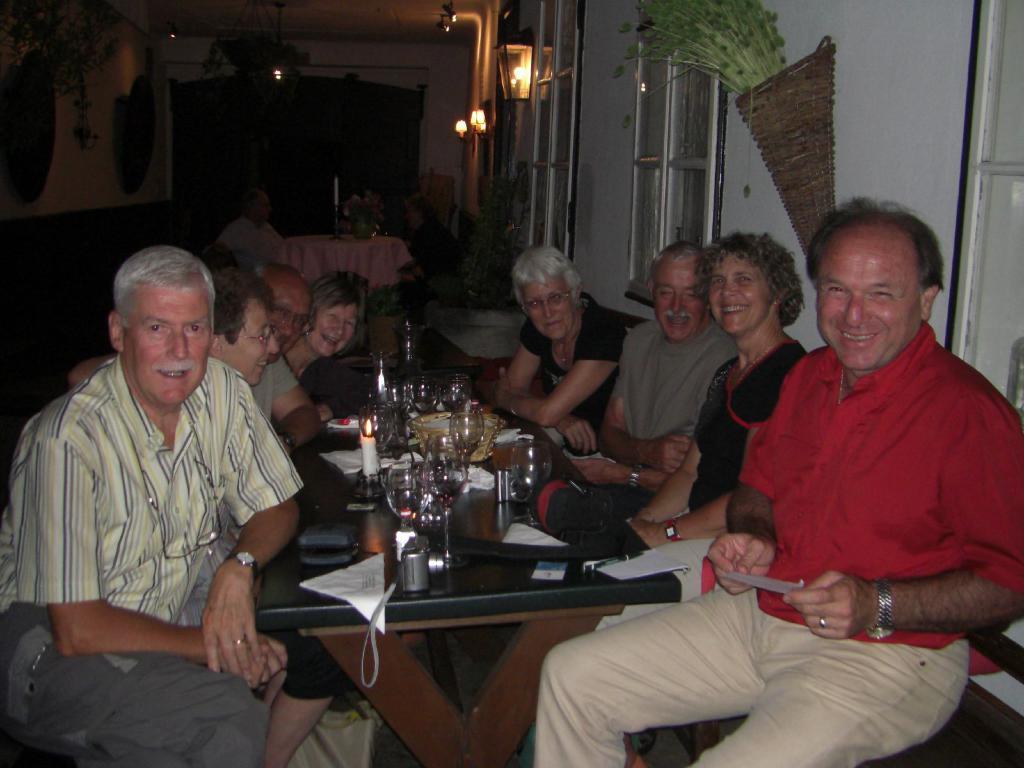How would you summarize this image in a sentence or two? As we can see in the image there is a light, wall, few people sitting on chairs and a table. On table there is a candles, glasses and papers. 